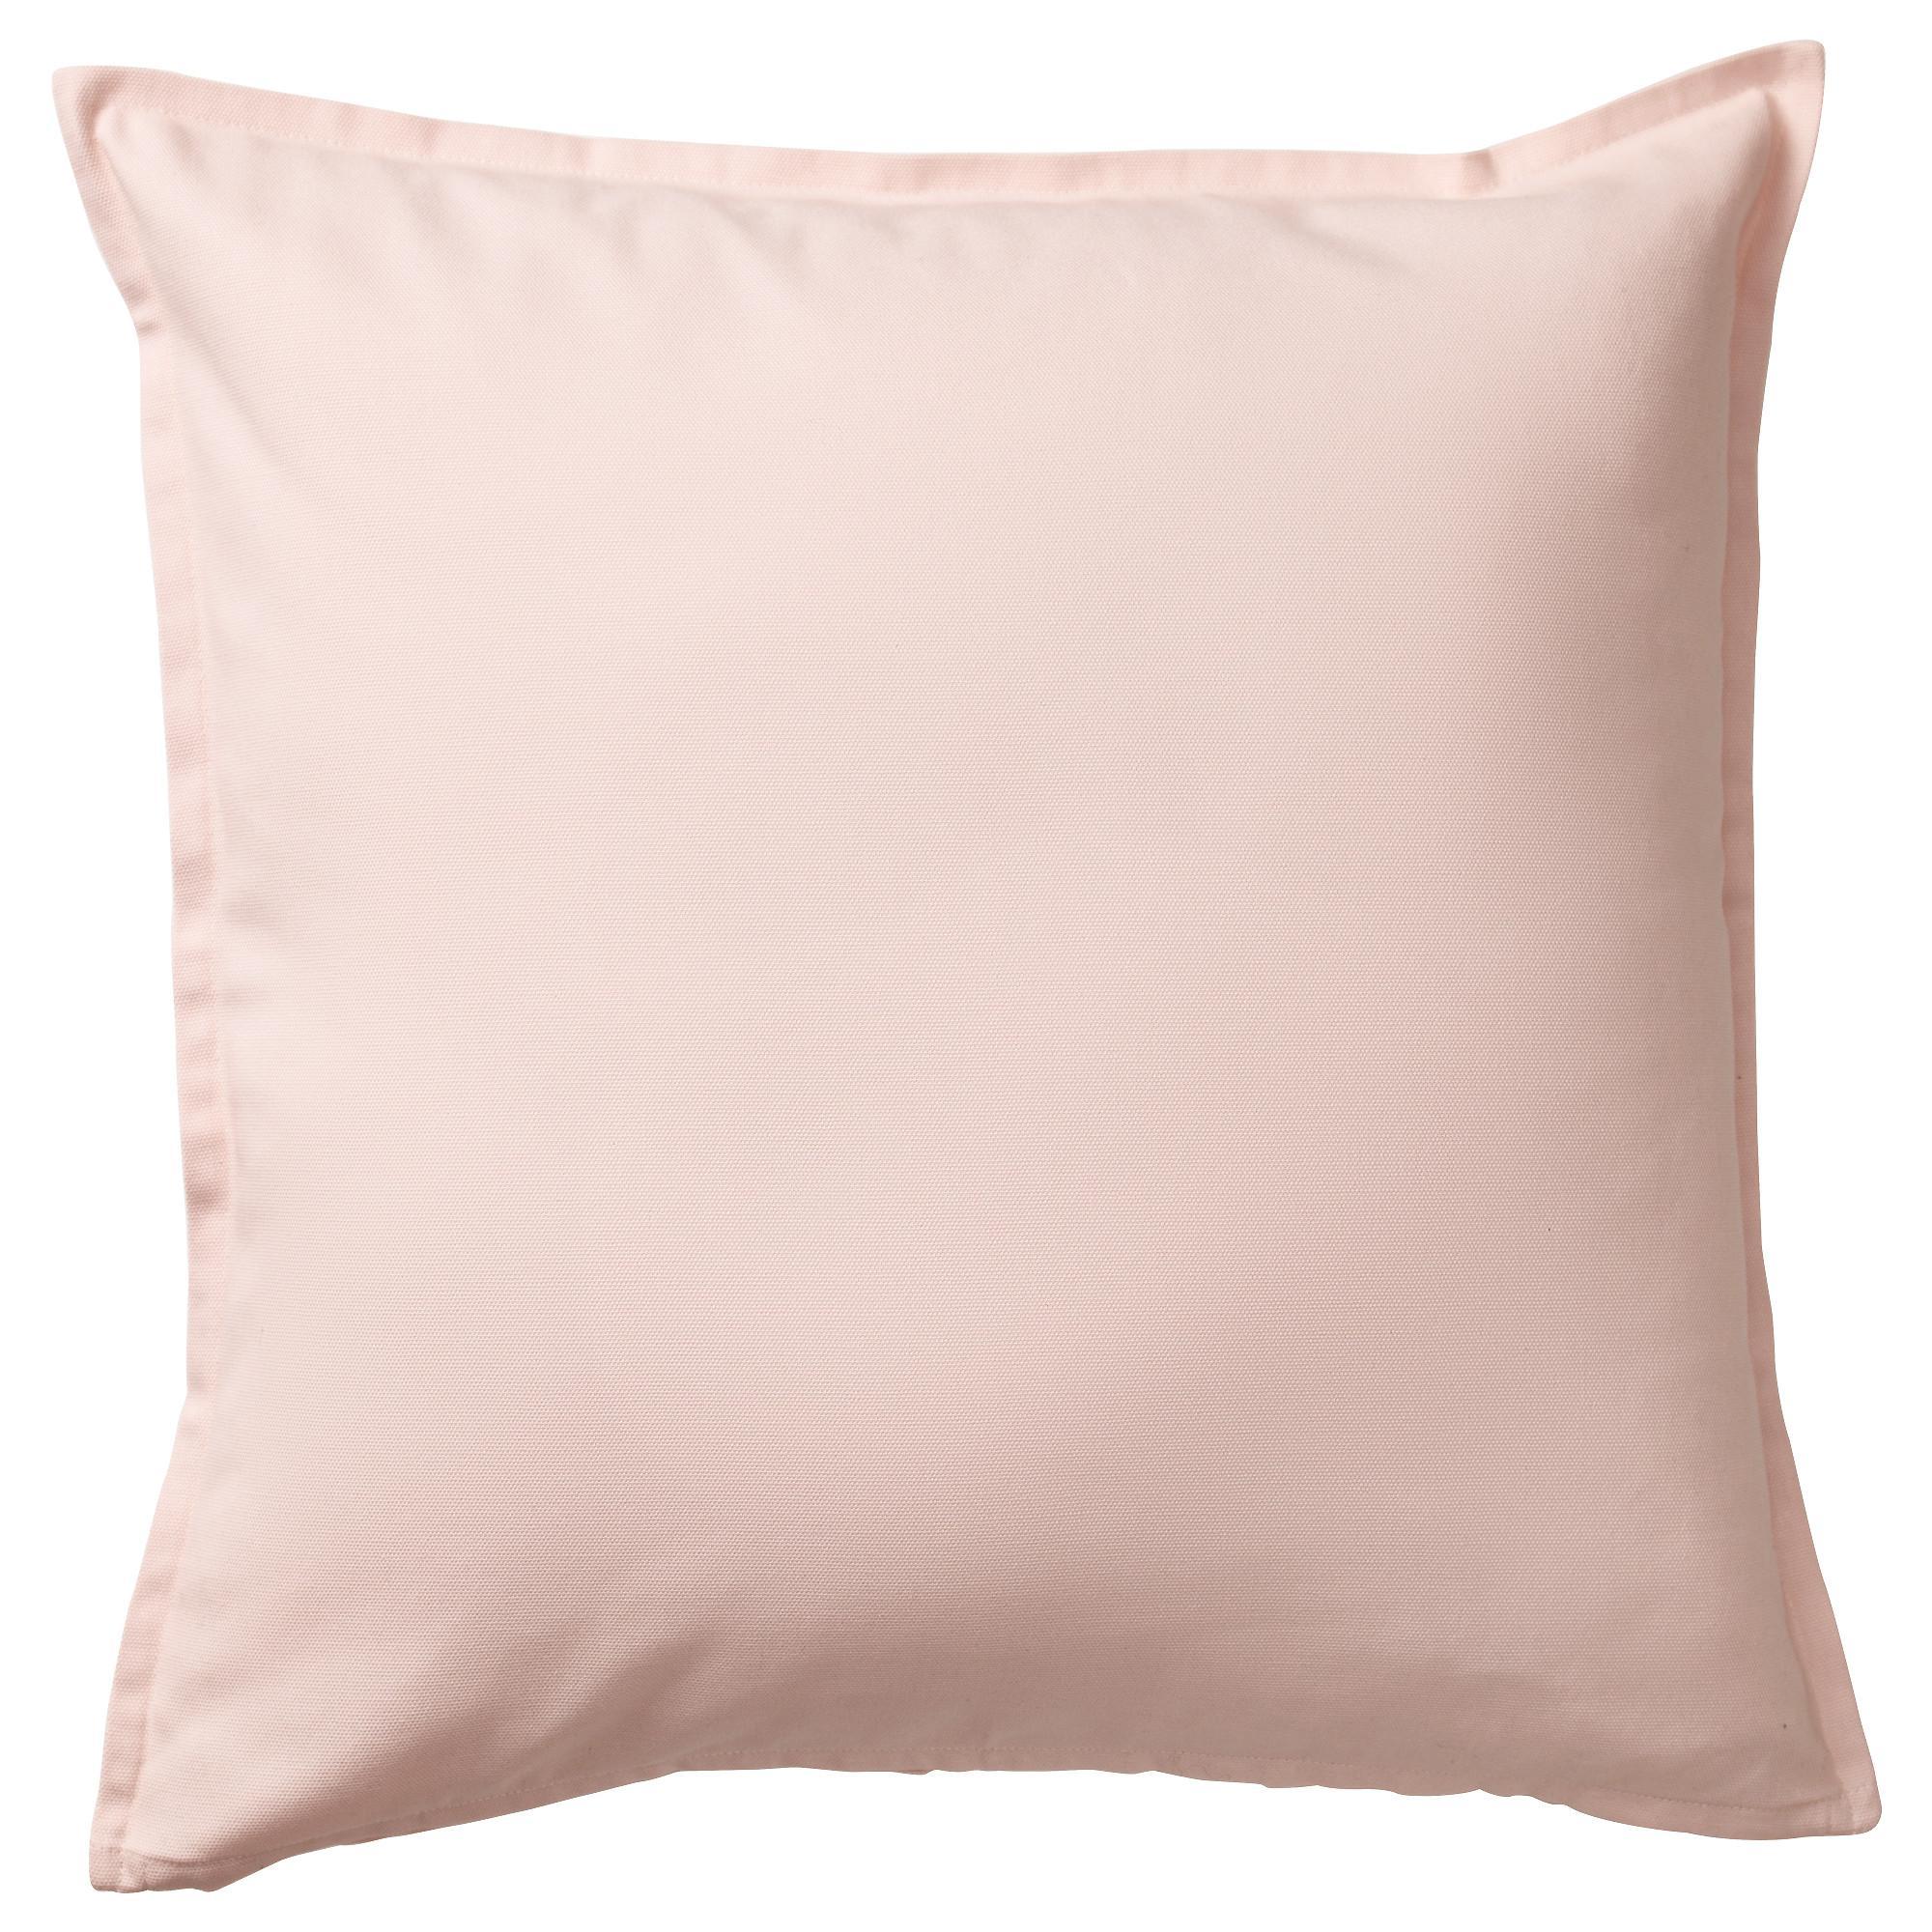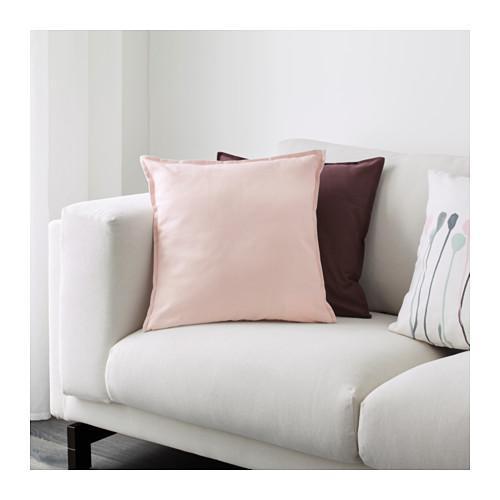The first image is the image on the left, the second image is the image on the right. For the images displayed, is the sentence "An image shows the corner of a white sofa containing a solid-colored pillow overlapping a striped pillow, and a smaller printed pillow to the right." factually correct? Answer yes or no. No. The first image is the image on the left, the second image is the image on the right. Assess this claim about the two images: "One image shows pillows on a sofa and the other shows a single pillow.". Correct or not? Answer yes or no. Yes. 